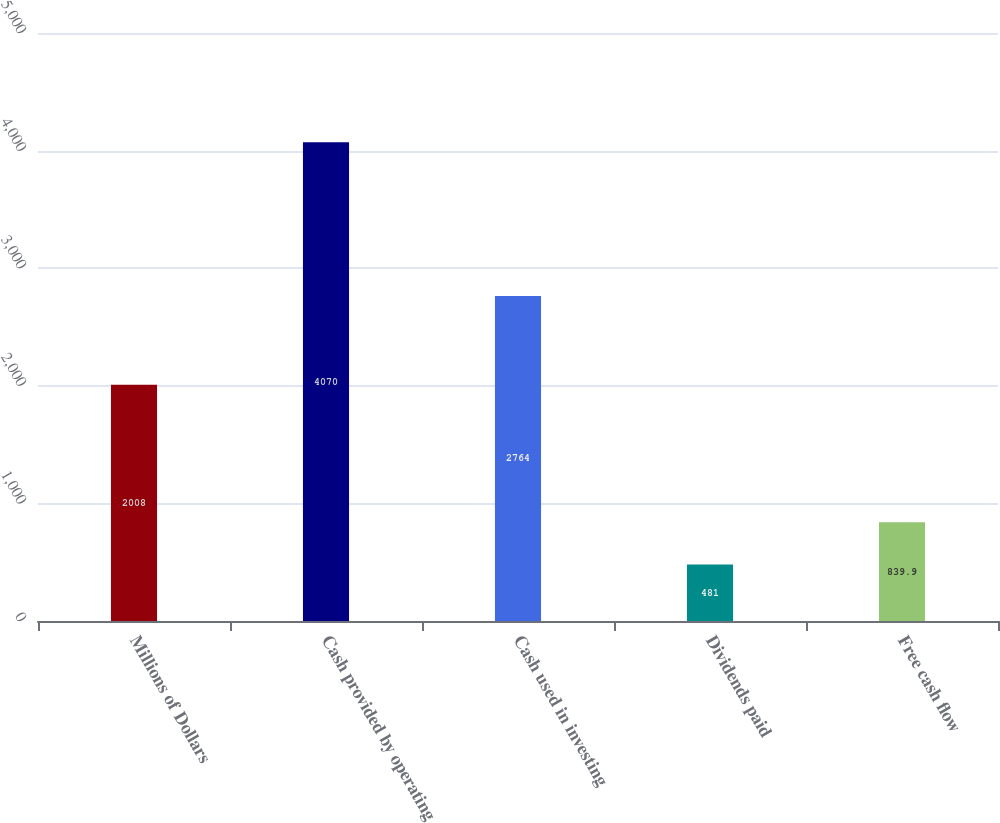<chart> <loc_0><loc_0><loc_500><loc_500><bar_chart><fcel>Millions of Dollars<fcel>Cash provided by operating<fcel>Cash used in investing<fcel>Dividends paid<fcel>Free cash flow<nl><fcel>2008<fcel>4070<fcel>2764<fcel>481<fcel>839.9<nl></chart> 